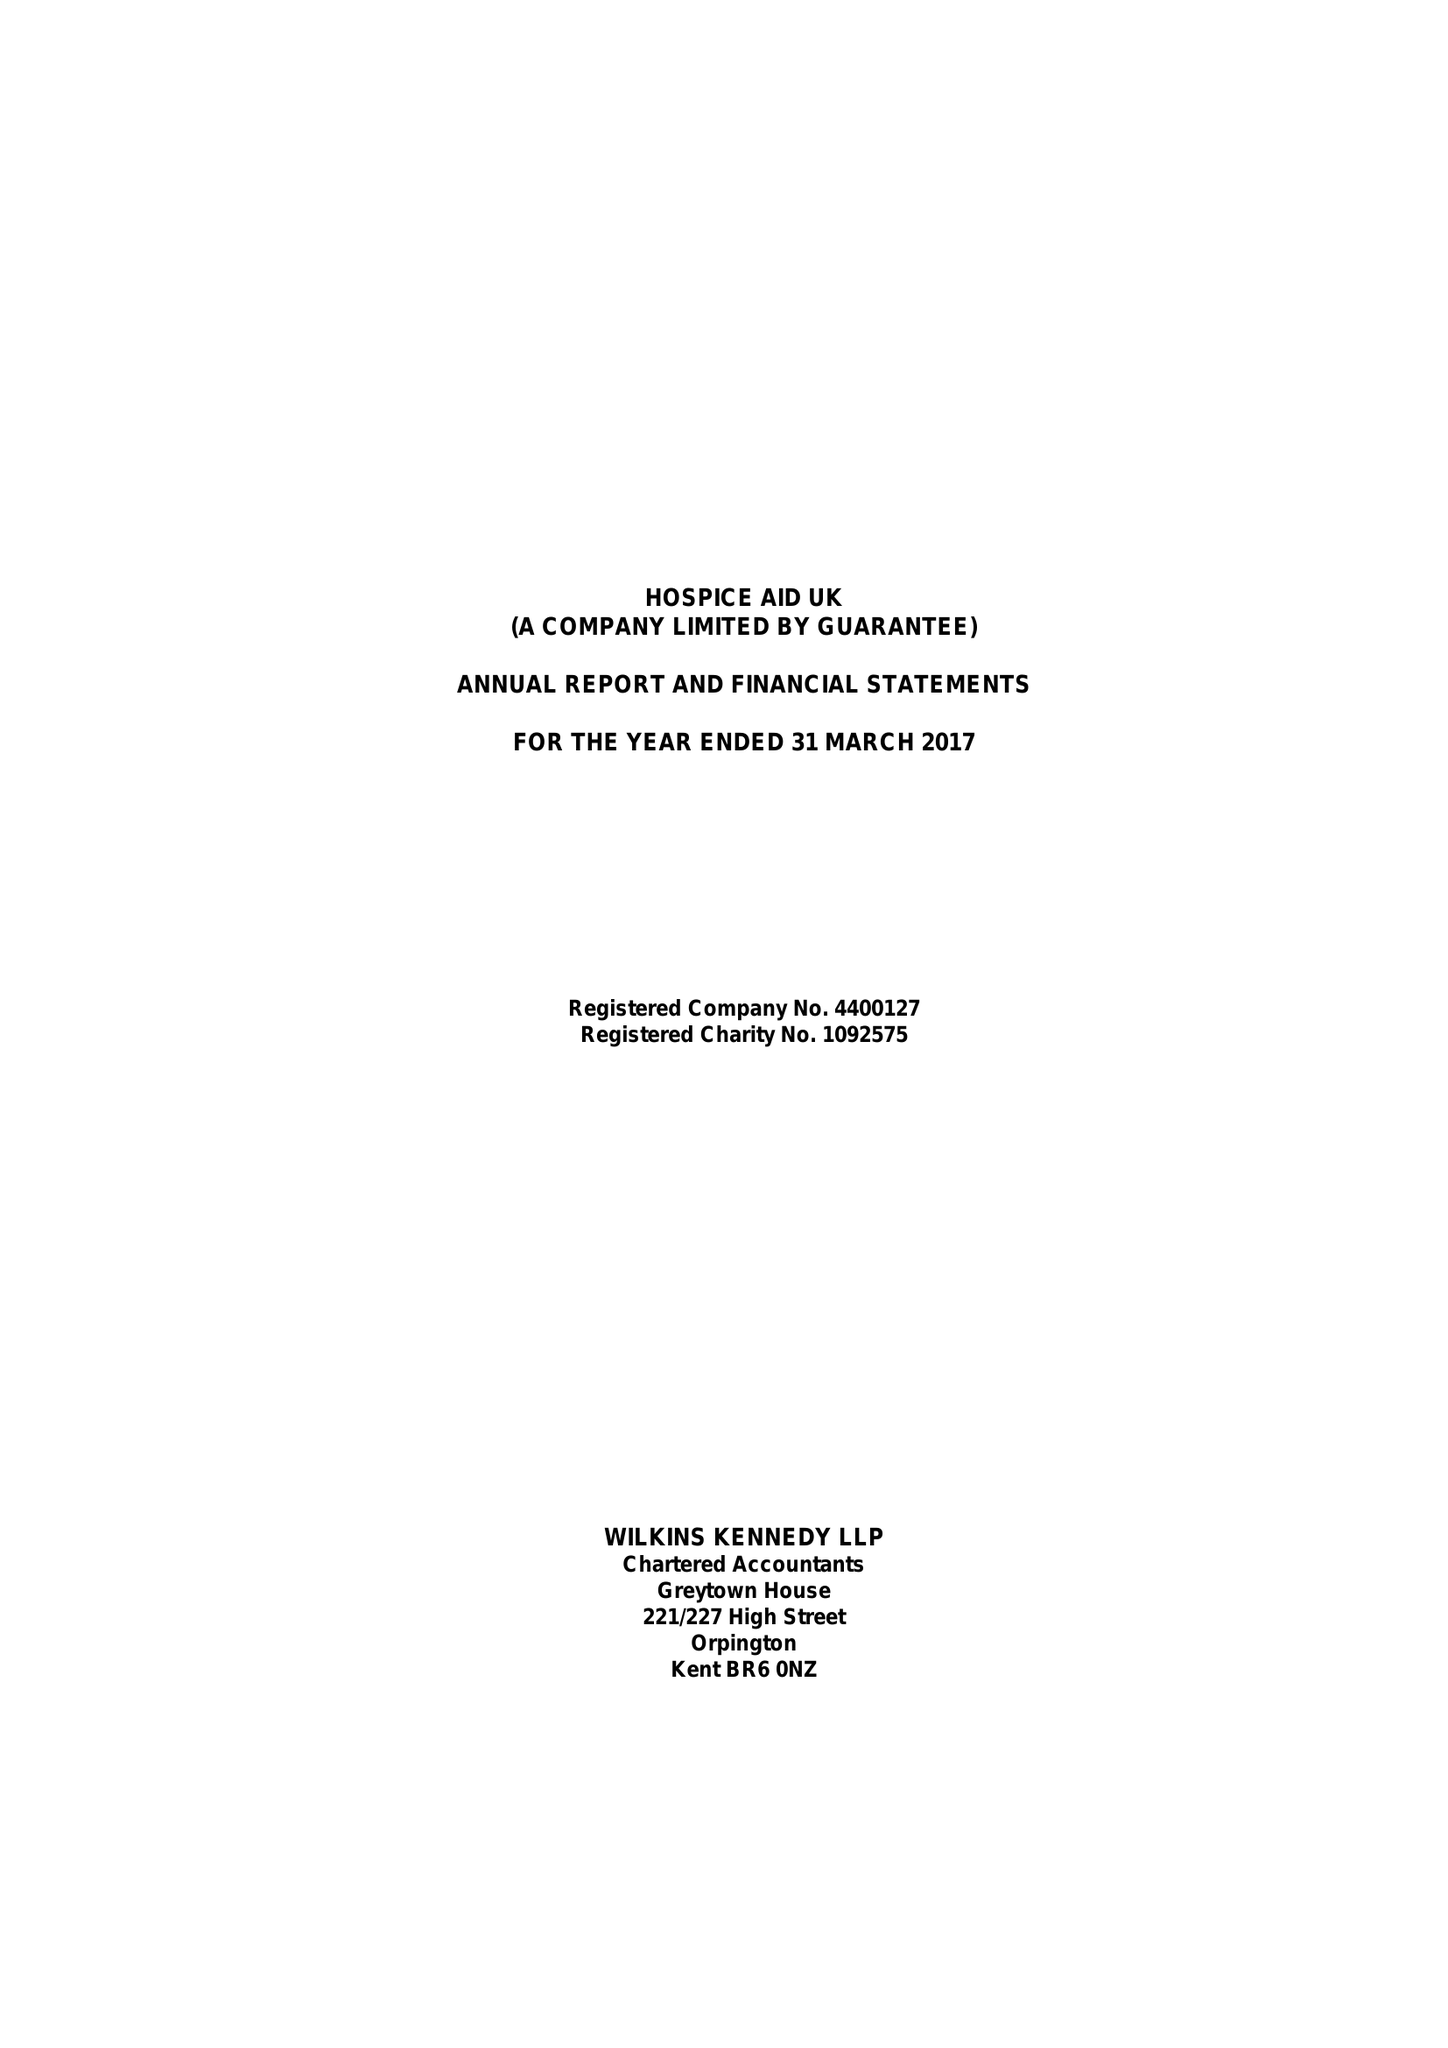What is the value for the income_annually_in_british_pounds?
Answer the question using a single word or phrase. 496088.00 